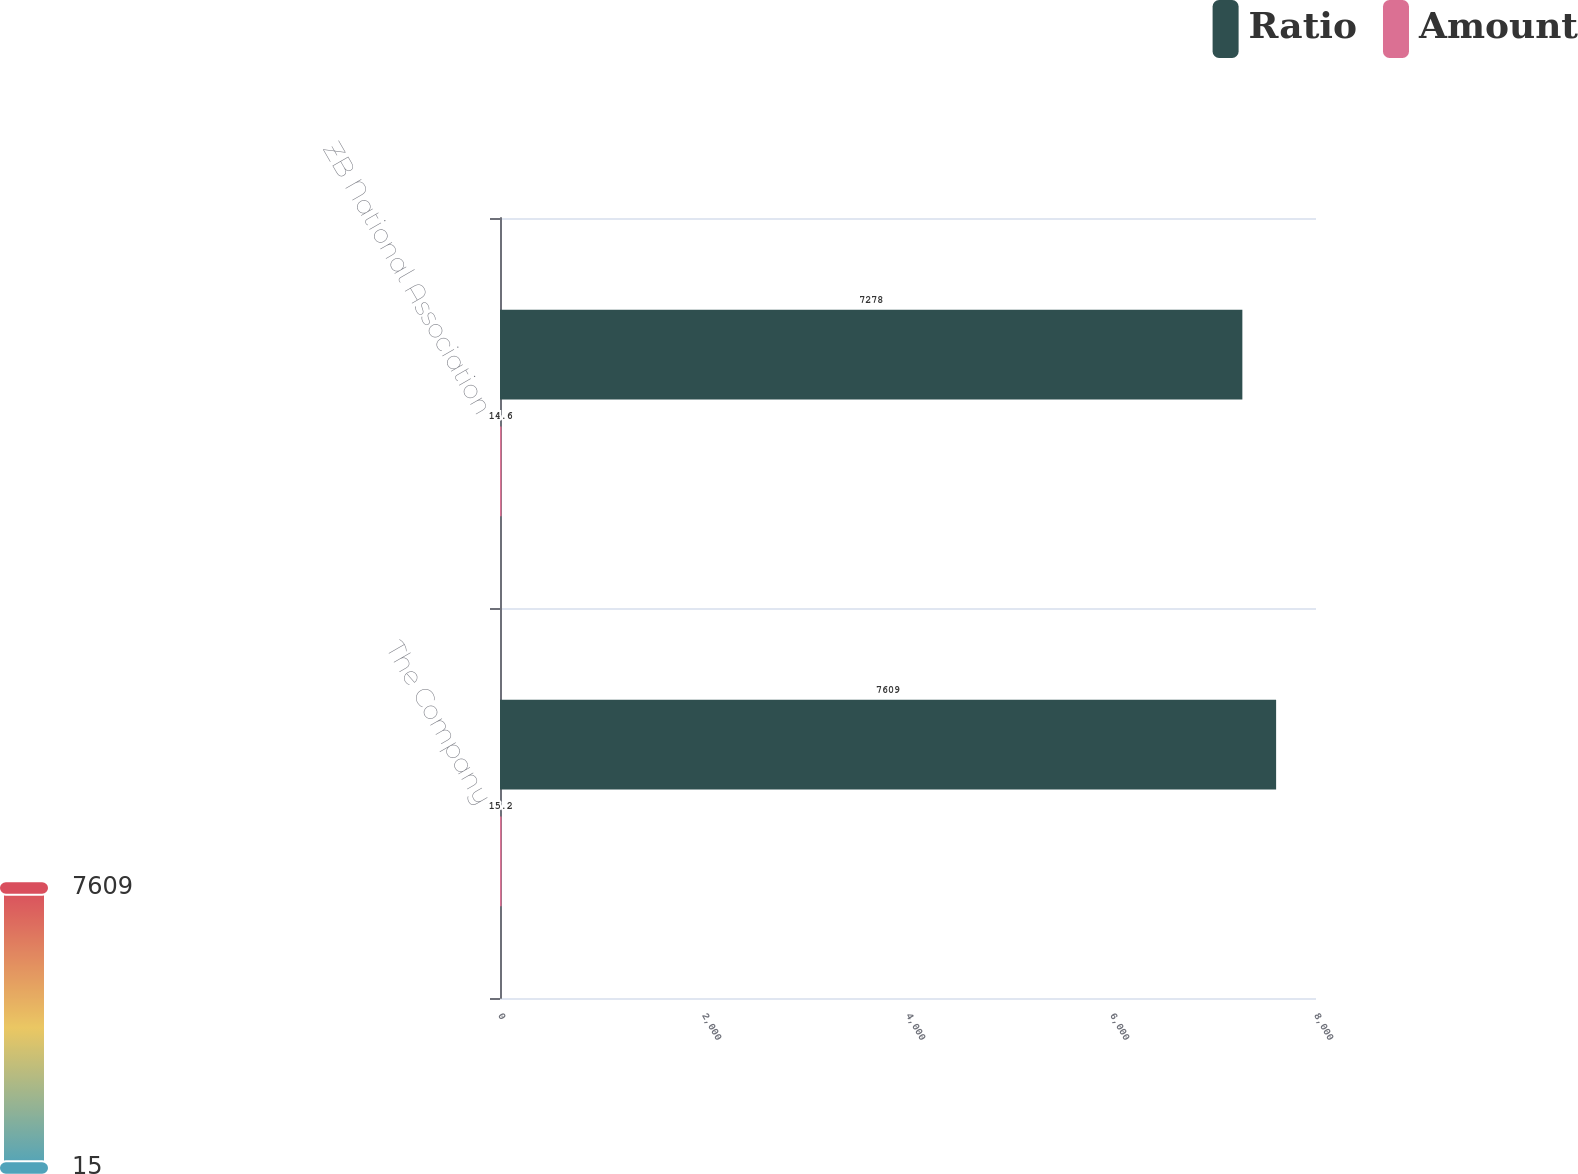Convert chart. <chart><loc_0><loc_0><loc_500><loc_500><stacked_bar_chart><ecel><fcel>The Company<fcel>ZB National Association<nl><fcel>Ratio<fcel>7609<fcel>7278<nl><fcel>Amount<fcel>15.2<fcel>14.6<nl></chart> 